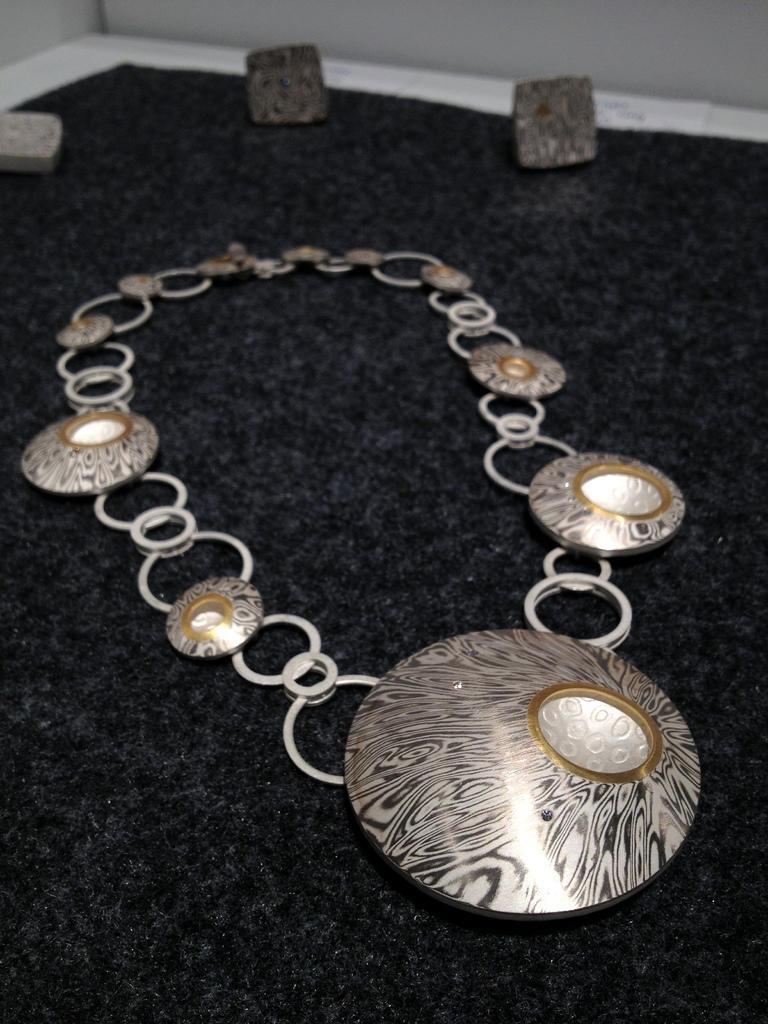Could you give a brief overview of what you see in this image? In the center of the image we can see necklace and stones placed on the table. 